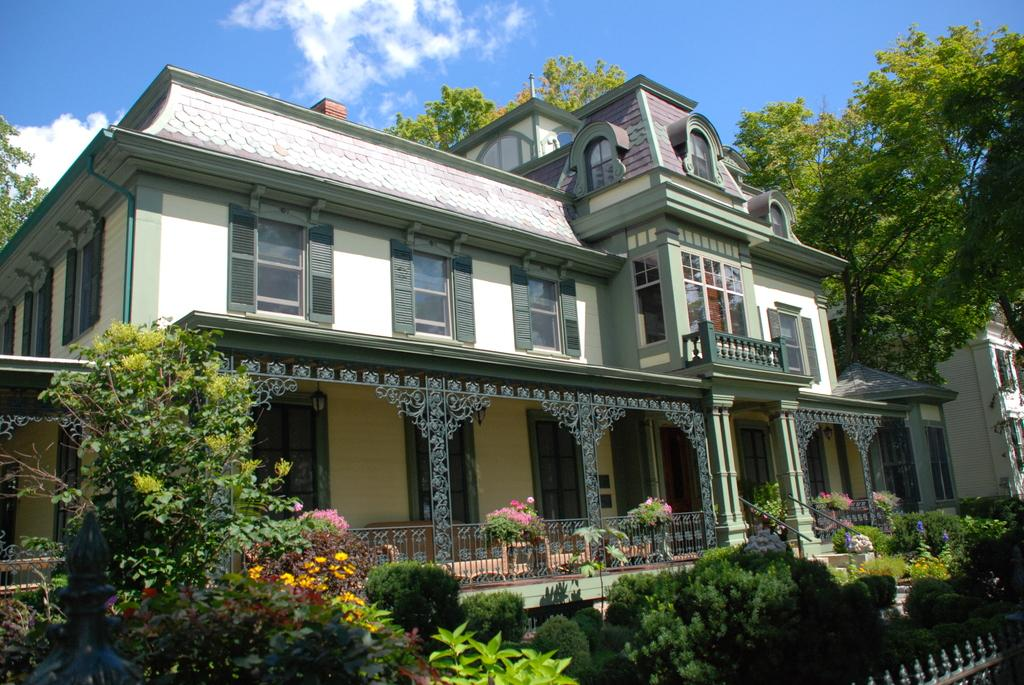What type of structures can be seen in the image? There are buildings in the image. What type of natural elements are present in the image? There are trees and plants in the image. Are there any architectural features visible in the image? Yes, there are stairs in the image. What is the entrance to the area like in the image? There is a gate in the image. What can be seen in the sky at the top of the image? There are clouds in the sky at the top of the image. What type of meal is being served at the playground in the image? There is no playground or meal present in the image. What type of doctor can be seen treating patients in the image? There is no doctor or patients present in the image. 